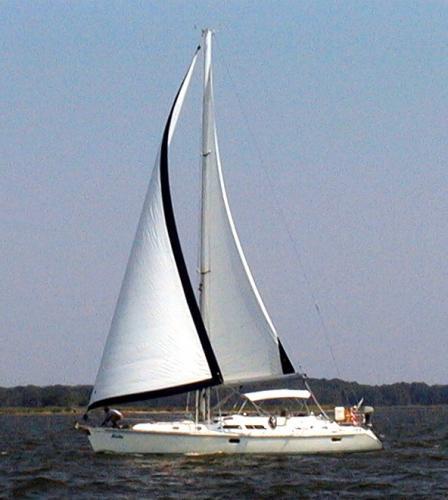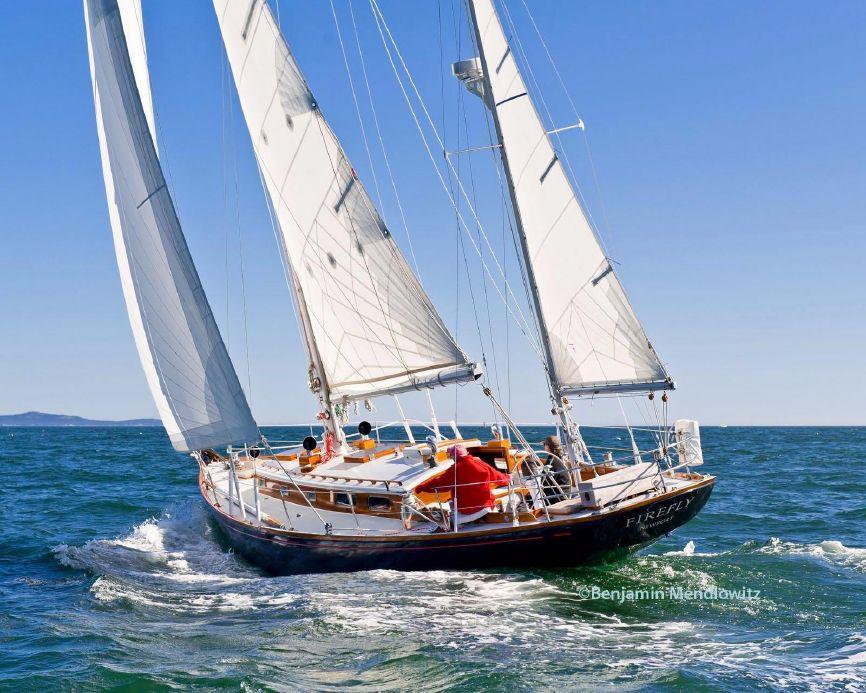The first image is the image on the left, the second image is the image on the right. Considering the images on both sides, is "White sea spray surrounds the boat in one of the images." valid? Answer yes or no. Yes. 